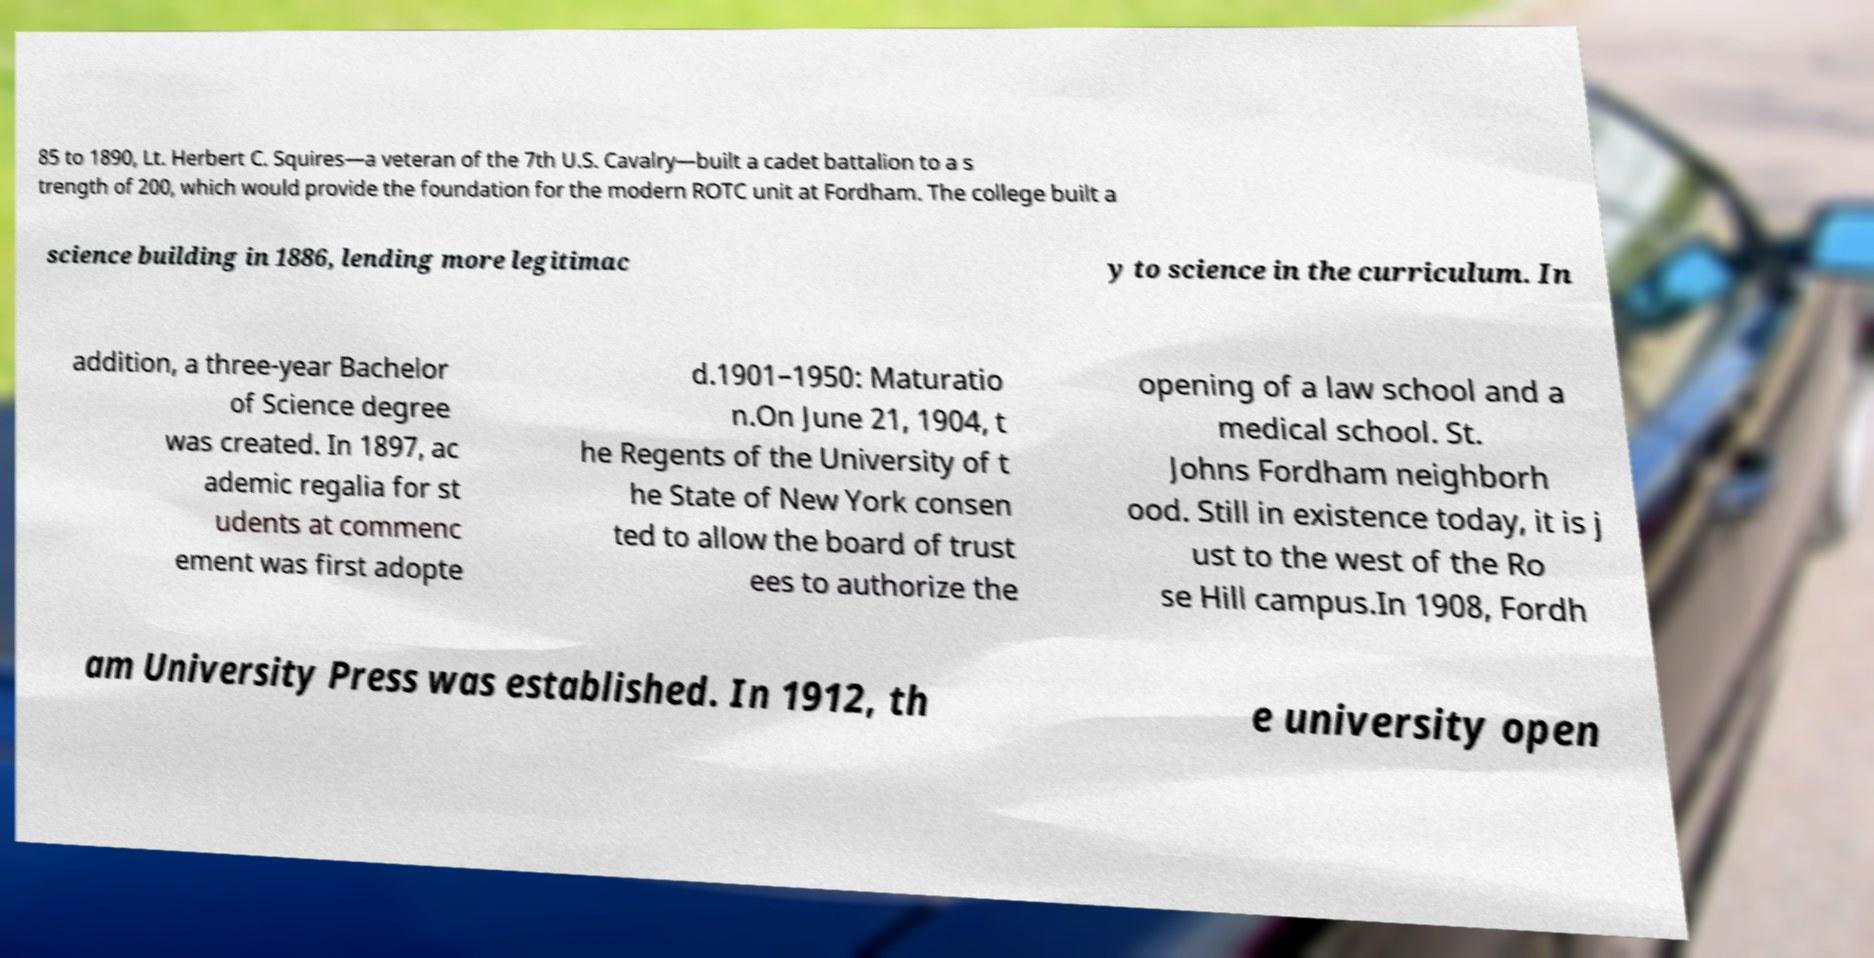There's text embedded in this image that I need extracted. Can you transcribe it verbatim? 85 to 1890, Lt. Herbert C. Squires—a veteran of the 7th U.S. Cavalry—built a cadet battalion to a s trength of 200, which would provide the foundation for the modern ROTC unit at Fordham. The college built a science building in 1886, lending more legitimac y to science in the curriculum. In addition, a three-year Bachelor of Science degree was created. In 1897, ac ademic regalia for st udents at commenc ement was first adopte d.1901–1950: Maturatio n.On June 21, 1904, t he Regents of the University of t he State of New York consen ted to allow the board of trust ees to authorize the opening of a law school and a medical school. St. Johns Fordham neighborh ood. Still in existence today, it is j ust to the west of the Ro se Hill campus.In 1908, Fordh am University Press was established. In 1912, th e university open 